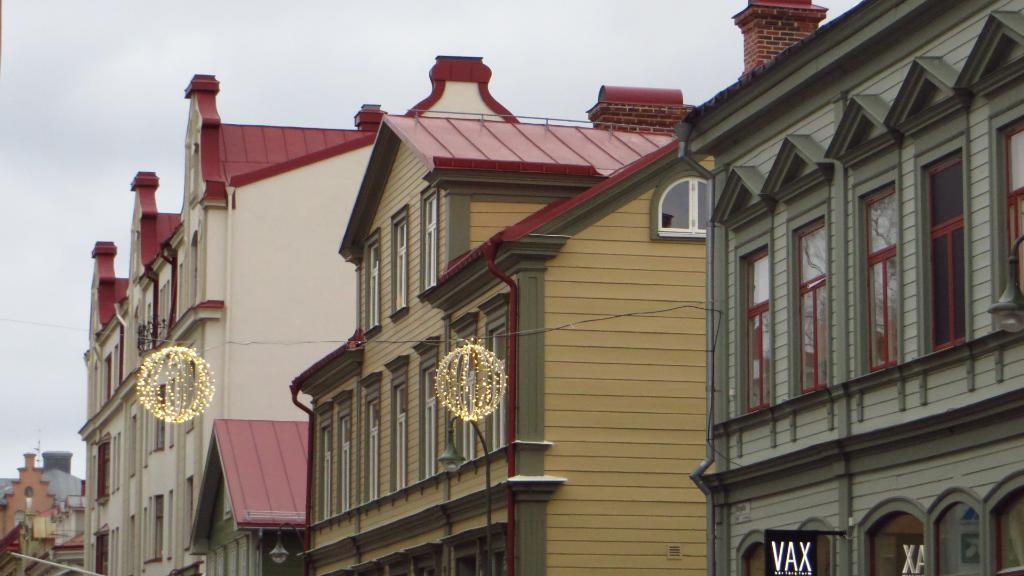Please provide a concise description of this image. This image is taken outdoors. At the top of the image there is a sky with clouds. In the middle of the image there are many buildings with walls, windows, doors and roofs. There is a pole with a street light. There are two rope lights. 